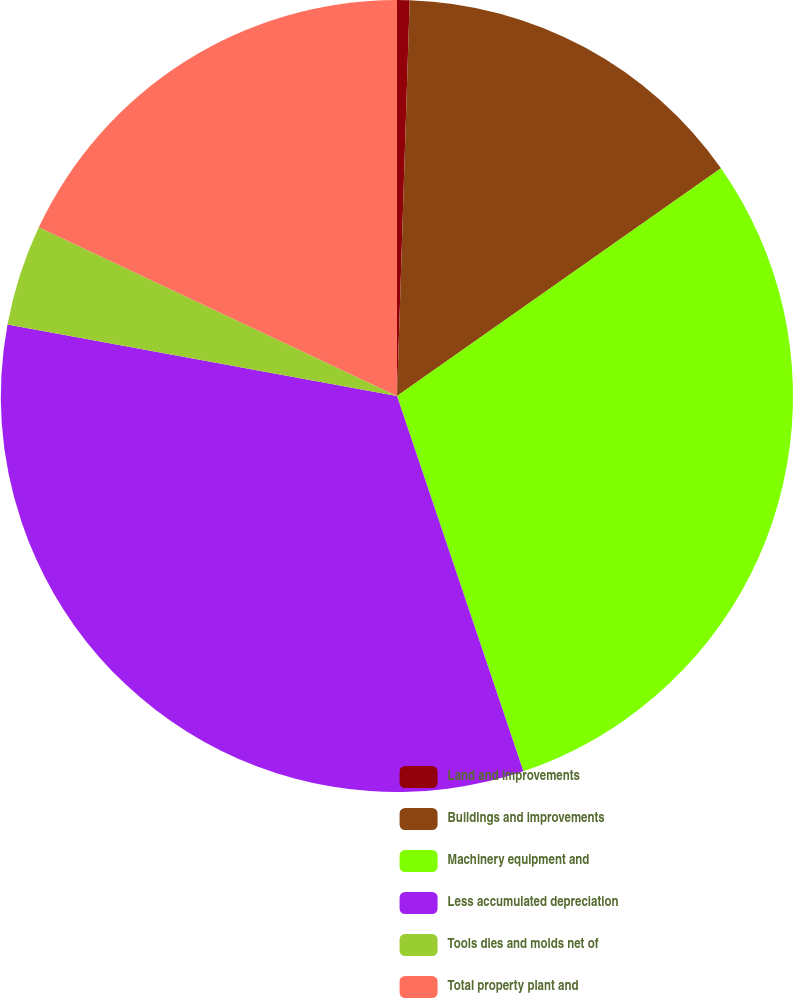Convert chart. <chart><loc_0><loc_0><loc_500><loc_500><pie_chart><fcel>Land and improvements<fcel>Buildings and improvements<fcel>Machinery equipment and<fcel>Less accumulated depreciation<fcel>Tools dies and molds net of<fcel>Total property plant and<nl><fcel>0.51%<fcel>14.74%<fcel>29.58%<fcel>33.06%<fcel>4.12%<fcel>17.99%<nl></chart> 